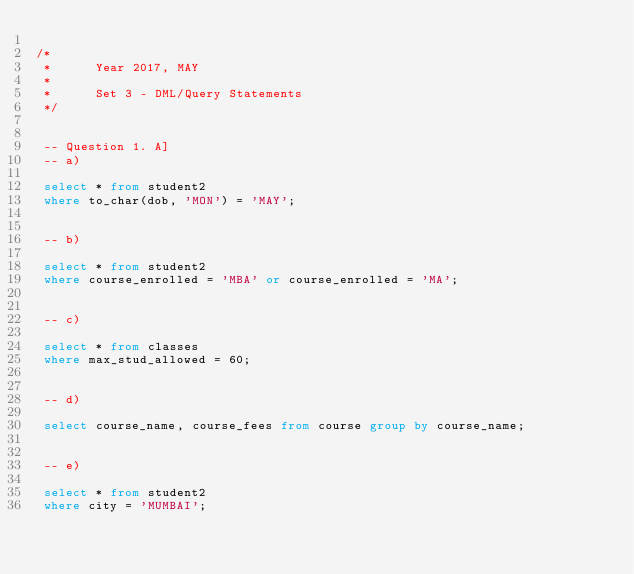Convert code to text. <code><loc_0><loc_0><loc_500><loc_500><_SQL_>
/*
 * 		Year 2017, MAY
 *
 *		Set 3 - DML/Query Statements
 */
 
 
 -- Question 1. A]
 -- a)
 
 select * from student2
 where to_char(dob, 'MON') = 'MAY';
 
 
 -- b)
 
 select * from student2
 where course_enrolled = 'MBA' or course_enrolled = 'MA';
 
 
 -- c)
 
 select * from classes
 where max_stud_allowed = 60;
 
 
 -- d)
 
 select course_name, course_fees from course group by course_name;
 
 
 -- e)
 
 select * from student2
 where city = 'MUMBAI';</code> 